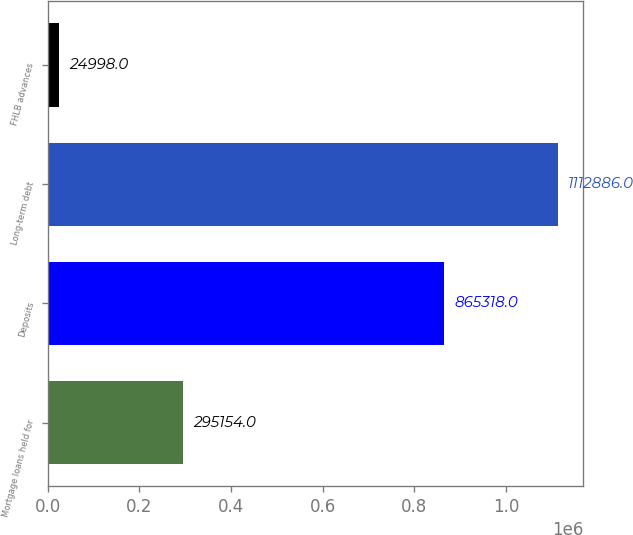<chart> <loc_0><loc_0><loc_500><loc_500><bar_chart><fcel>Mortgage loans held for<fcel>Deposits<fcel>Long-term debt<fcel>FHLB advances<nl><fcel>295154<fcel>865318<fcel>1.11289e+06<fcel>24998<nl></chart> 